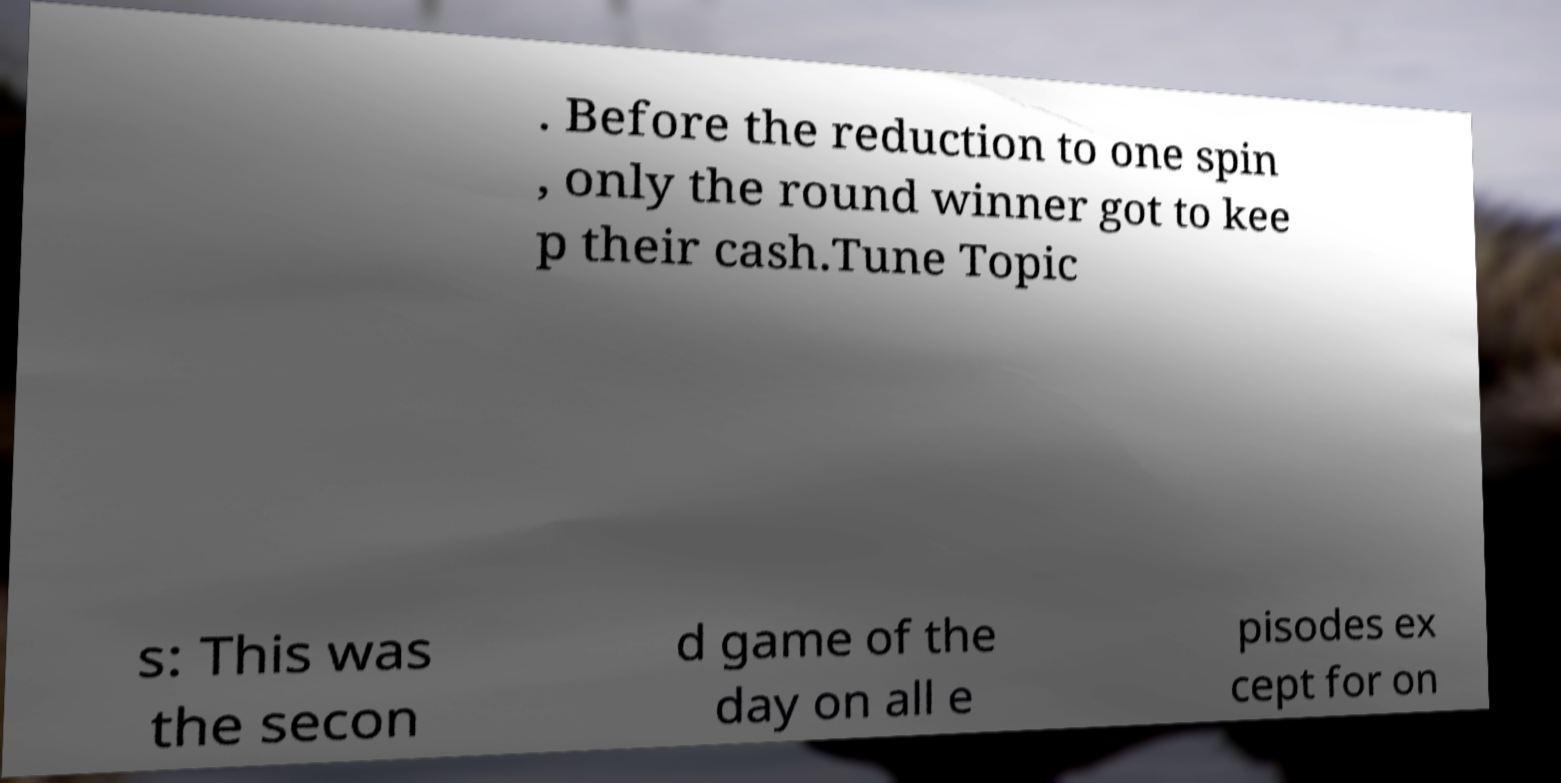Please identify and transcribe the text found in this image. . Before the reduction to one spin , only the round winner got to kee p their cash.Tune Topic s: This was the secon d game of the day on all e pisodes ex cept for on 